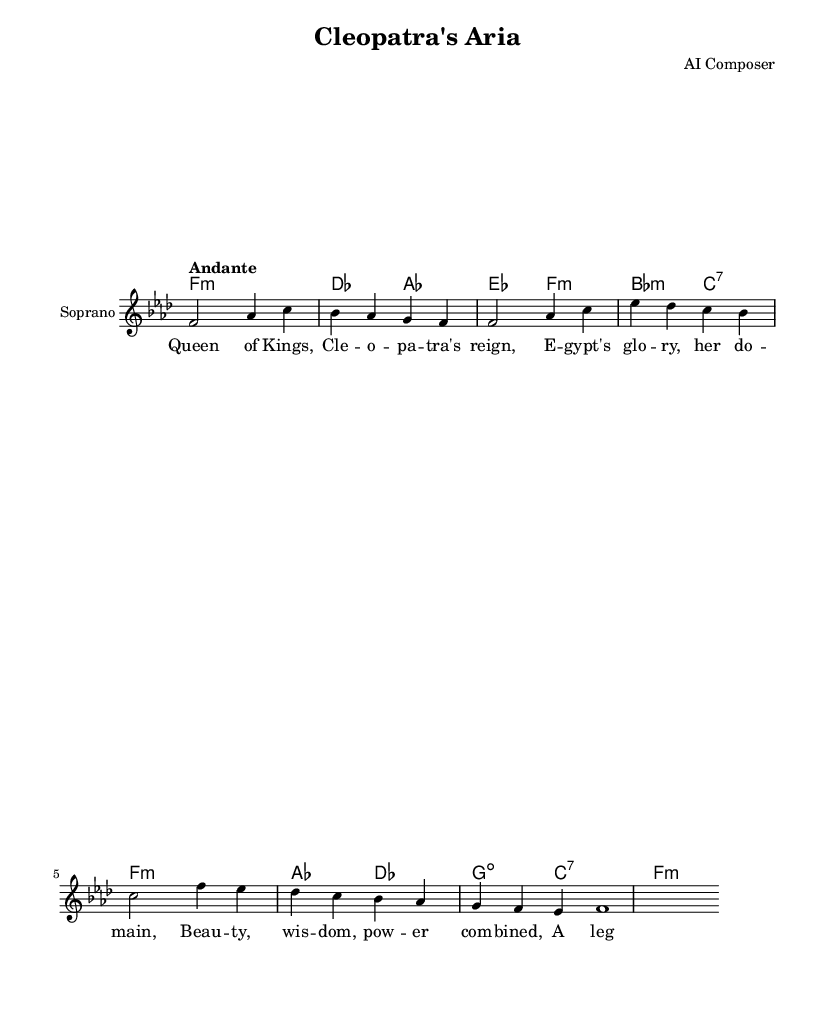What is the key signature of this music? The key signature is F minor, which is indicated by the presence of four flats (B♭, E♭, A♭, and D♭). This can be seen at the beginning of the staff.
Answer: F minor What is the time signature of the piece? The time signature is 4/4, which is shown at the beginning of the music and indicates that there are four beats in each measure.
Answer: 4/4 What is the tempo marking for this piece? The tempo marking is "Andante," which suggests a moderate pace and can be found at the beginning above the staff.
Answer: Andante How many measures are in the melody section? The melody section consists of eight measures, as the notation shows a total of eight bars. This can be counted from the beginning to the last measure.
Answer: 8 What is the vocal range indicated in this score? The score indicates that the vocal range for this piece is for Soprano as indicated in the staff heading.
Answer: Soprano What historical figure does this aria celebrate? The aria celebrates Cleopatra, as indicated by the lyrics that reference her reign and achievements in the text.
Answer: Cleopatra How many chords are used in the harmony section? The harmony section uses a total of eight different chords as indicated in the chord symbols written in the score throughout the harmonic progression.
Answer: 8 